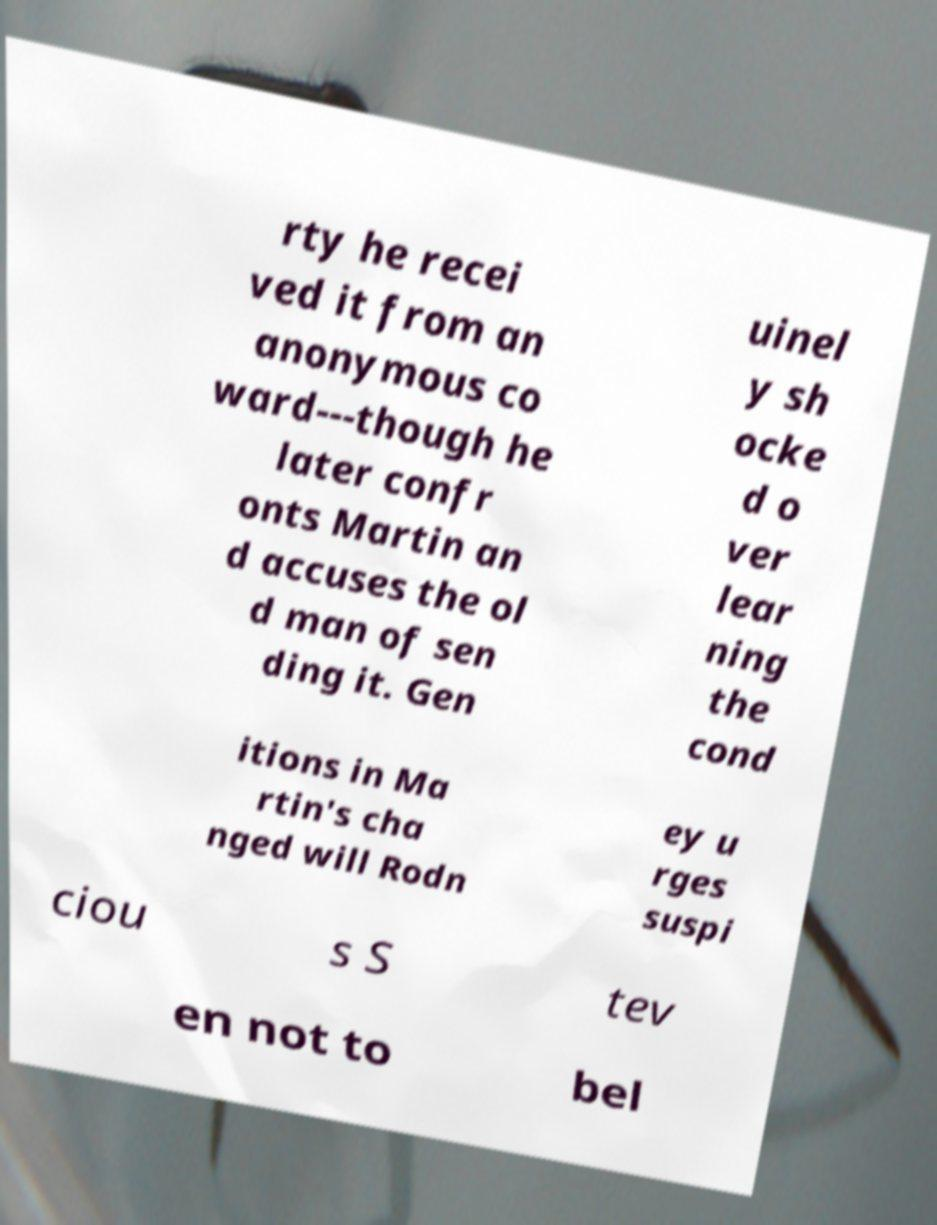For documentation purposes, I need the text within this image transcribed. Could you provide that? rty he recei ved it from an anonymous co ward---though he later confr onts Martin an d accuses the ol d man of sen ding it. Gen uinel y sh ocke d o ver lear ning the cond itions in Ma rtin's cha nged will Rodn ey u rges suspi ciou s S tev en not to bel 